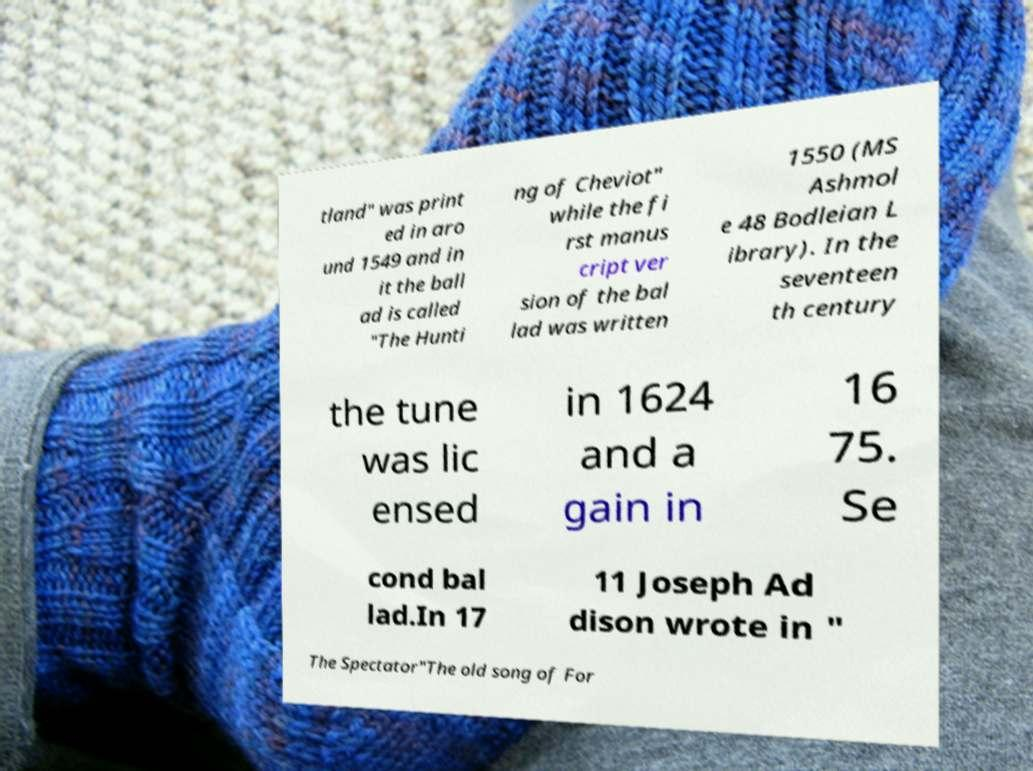Can you accurately transcribe the text from the provided image for me? tland" was print ed in aro und 1549 and in it the ball ad is called "The Hunti ng of Cheviot" while the fi rst manus cript ver sion of the bal lad was written 1550 (MS Ashmol e 48 Bodleian L ibrary). In the seventeen th century the tune was lic ensed in 1624 and a gain in 16 75. Se cond bal lad.In 17 11 Joseph Ad dison wrote in " The Spectator"The old song of For 